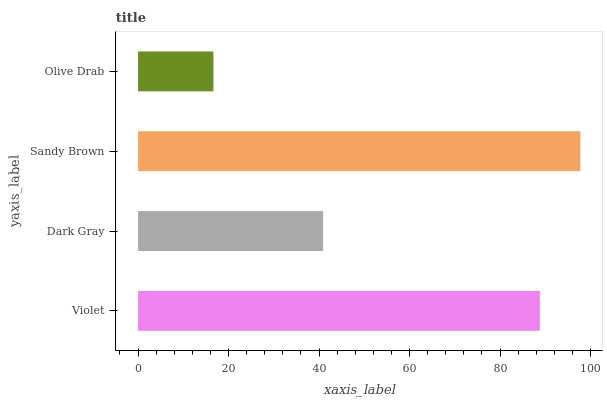Is Olive Drab the minimum?
Answer yes or no. Yes. Is Sandy Brown the maximum?
Answer yes or no. Yes. Is Dark Gray the minimum?
Answer yes or no. No. Is Dark Gray the maximum?
Answer yes or no. No. Is Violet greater than Dark Gray?
Answer yes or no. Yes. Is Dark Gray less than Violet?
Answer yes or no. Yes. Is Dark Gray greater than Violet?
Answer yes or no. No. Is Violet less than Dark Gray?
Answer yes or no. No. Is Violet the high median?
Answer yes or no. Yes. Is Dark Gray the low median?
Answer yes or no. Yes. Is Dark Gray the high median?
Answer yes or no. No. Is Olive Drab the low median?
Answer yes or no. No. 